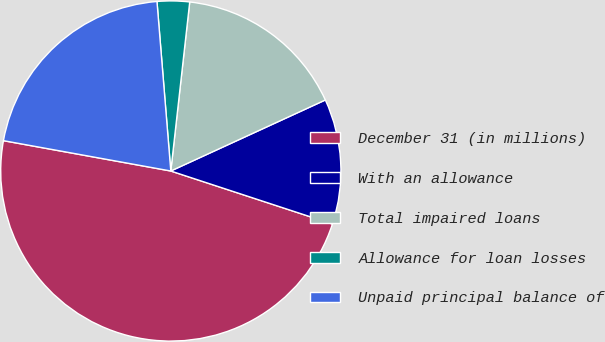<chart> <loc_0><loc_0><loc_500><loc_500><pie_chart><fcel>December 31 (in millions)<fcel>With an allowance<fcel>Total impaired loans<fcel>Allowance for loan losses<fcel>Unpaid principal balance of<nl><fcel>47.81%<fcel>11.9%<fcel>16.37%<fcel>3.07%<fcel>20.85%<nl></chart> 